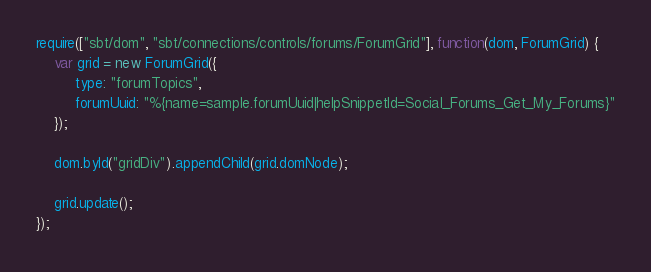Convert code to text. <code><loc_0><loc_0><loc_500><loc_500><_JavaScript_>require(["sbt/dom", "sbt/connections/controls/forums/ForumGrid"], function(dom, ForumGrid) {
    var grid = new ForumGrid({
         type: "forumTopics",
         forumUuid: "%{name=sample.forumUuid|helpSnippetId=Social_Forums_Get_My_Forums}"
    });
             
    dom.byId("gridDiv").appendChild(grid.domNode);
             
    grid.update();
});

</code> 